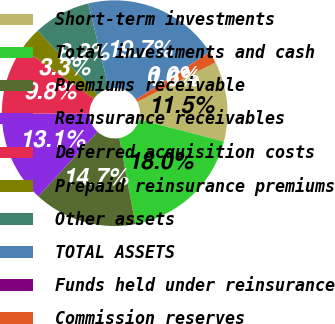Convert chart to OTSL. <chart><loc_0><loc_0><loc_500><loc_500><pie_chart><fcel>Short-term investments<fcel>Total investments and cash<fcel>Premiums receivable<fcel>Reinsurance receivables<fcel>Deferred acquisition costs<fcel>Prepaid reinsurance premiums<fcel>Other assets<fcel>TOTAL ASSETS<fcel>Funds held under reinsurance<fcel>Commission reserves<nl><fcel>11.47%<fcel>18.02%<fcel>14.75%<fcel>13.11%<fcel>9.84%<fcel>3.29%<fcel>8.2%<fcel>19.66%<fcel>0.01%<fcel>1.65%<nl></chart> 